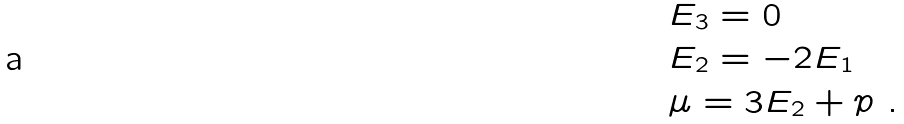<formula> <loc_0><loc_0><loc_500><loc_500>& E _ { 3 } = 0 \\ & E _ { 2 } = - 2 E _ { 1 } \\ & \mu = 3 E _ { 2 } + p \ .</formula> 